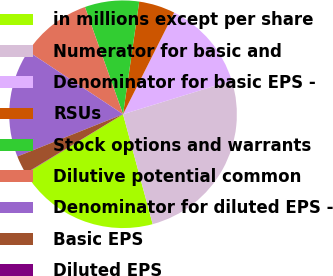Convert chart. <chart><loc_0><loc_0><loc_500><loc_500><pie_chart><fcel>in millions except per share<fcel>Numerator for basic and<fcel>Denominator for basic EPS -<fcel>RSUs<fcel>Stock options and warrants<fcel>Dilutive potential common<fcel>Denominator for diluted EPS -<fcel>Basic EPS<fcel>Diluted EPS<nl><fcel>20.49%<fcel>25.58%<fcel>12.81%<fcel>5.15%<fcel>7.7%<fcel>10.26%<fcel>15.36%<fcel>2.6%<fcel>0.05%<nl></chart> 